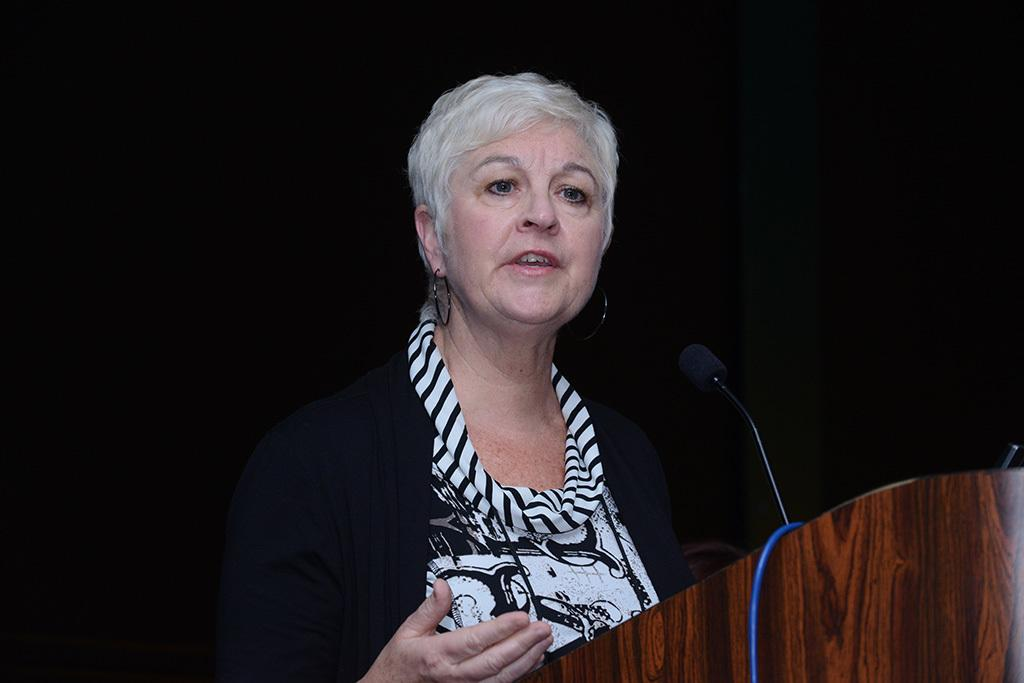What is happening on the stage in the image? There is a person on the stage. What is the person doing on the stage? The person is in front of a microphone. What can be seen on the podium in the image? There is a cable on the podium. What type of popcorn is being served to the audience in the image? There is no popcorn present in the image. How does the person on stage appear to be feeling while using the microphone? The image does not provide information about the person's emotions or nerves. 